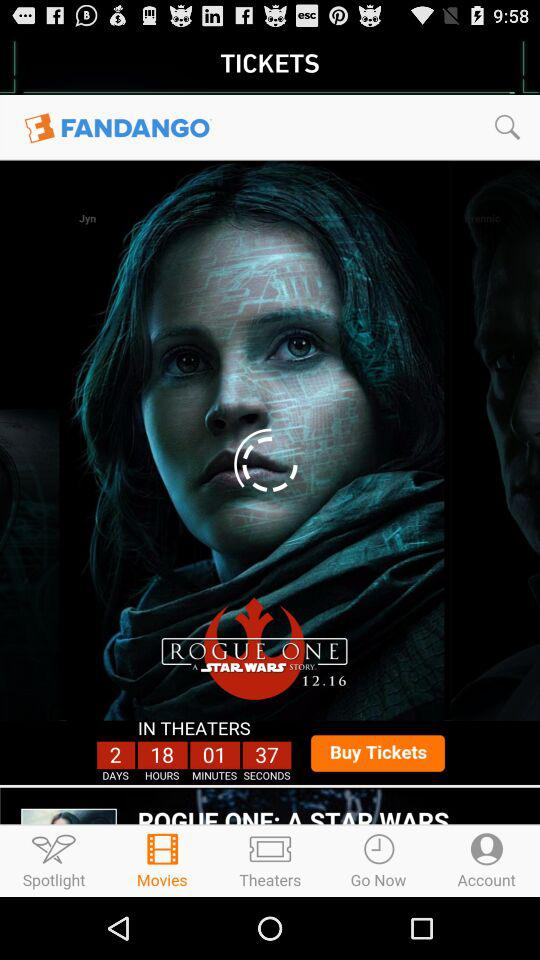When will the movie be released in theaters? The movie will be released in 2 days 18 hours 1 minute 37 seconds. 